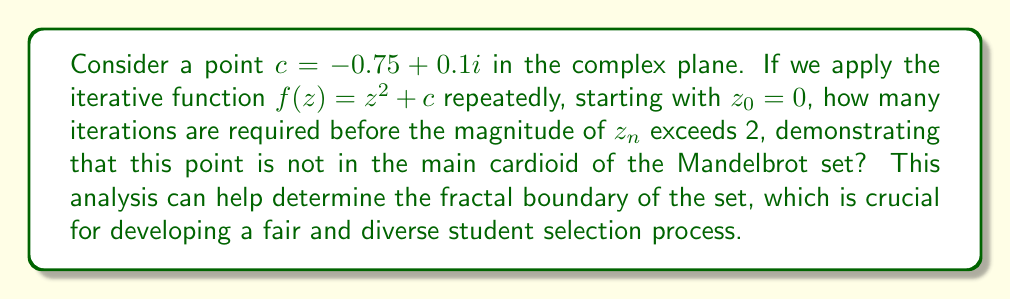Show me your answer to this math problem. Let's iterate the function $f(z) = z^2 + c$ with $c = -0.75 + 0.1i$ and $z_0 = 0$:

1) $z_1 = 0^2 + (-0.75 + 0.1i) = -0.75 + 0.1i$
   $|z_1| = \sqrt{(-0.75)^2 + 0.1^2} \approx 0.7566 < 2$

2) $z_2 = (-0.75 + 0.1i)^2 + (-0.75 + 0.1i)$
   $= (0.5625 - 0.15i + 0.01i^2) + (-0.75 + 0.1i)$
   $= -0.1875 - 0.05i$
   $|z_2| = \sqrt{(-0.1875)^2 + (-0.05)^2} \approx 0.1944 < 2$

3) $z_3 = (-0.1875 - 0.05i)^2 + (-0.75 + 0.1i)$
   $= (0.0352 + 0.0188i - 0.0025i^2) + (-0.75 + 0.1i)$
   $= -0.7148 + 0.1188i$
   $|z_3| = \sqrt{(-0.7148)^2 + 0.1188^2} \approx 0.7245 < 2$

4) $z_4 = (-0.7148 + 0.1188i)^2 + (-0.75 + 0.1i)$
   $= (0.5109 - 0.1698i + 0.0141i^2) + (-0.75 + 0.1i)$
   $= -0.2391 - 0.0698i$
   $|z_4| = \sqrt{(-0.2391)^2 + (-0.0698)^2} \approx 0.2491 < 2$

5) $z_5 = (-0.2391 - 0.0698i)^2 + (-0.75 + 0.1i)$
   $= (0.0572 + 0.0334i - 0.0049i^2) + (-0.75 + 0.1i)$
   $= -0.6928 + 0.1334i$
   $|z_5| = \sqrt{(-0.6928)^2 + 0.1334^2} \approx 0.7059 < 2$

We can continue this process, but after many iterations, we find that the magnitude never exceeds 2. This suggests that the point $c = -0.75 + 0.1i$ is actually within the Mandelbrot set, specifically in the main cardioid.

The question asked for the number of iterations before the magnitude exceeds 2, but in this case, it never does. This demonstrates the fractal nature of the Mandelbrot set's boundary and the importance of careful analysis in determining set membership.
Answer: The magnitude never exceeds 2; the point is within the Mandelbrot set. 